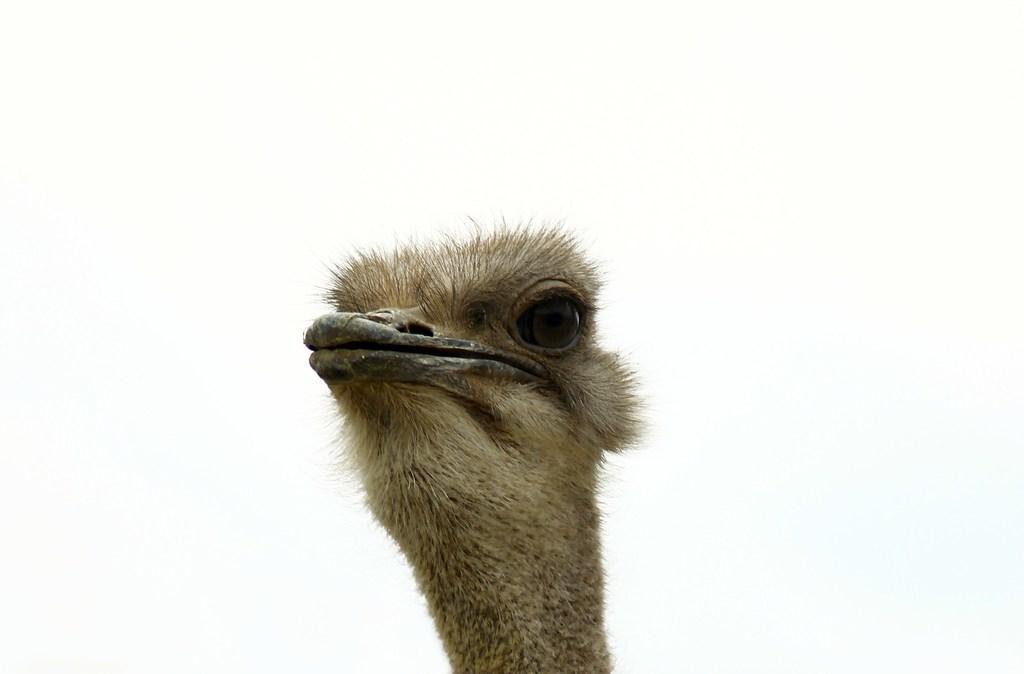Please provide a concise description of this image. This is ostrich, this is white color. 